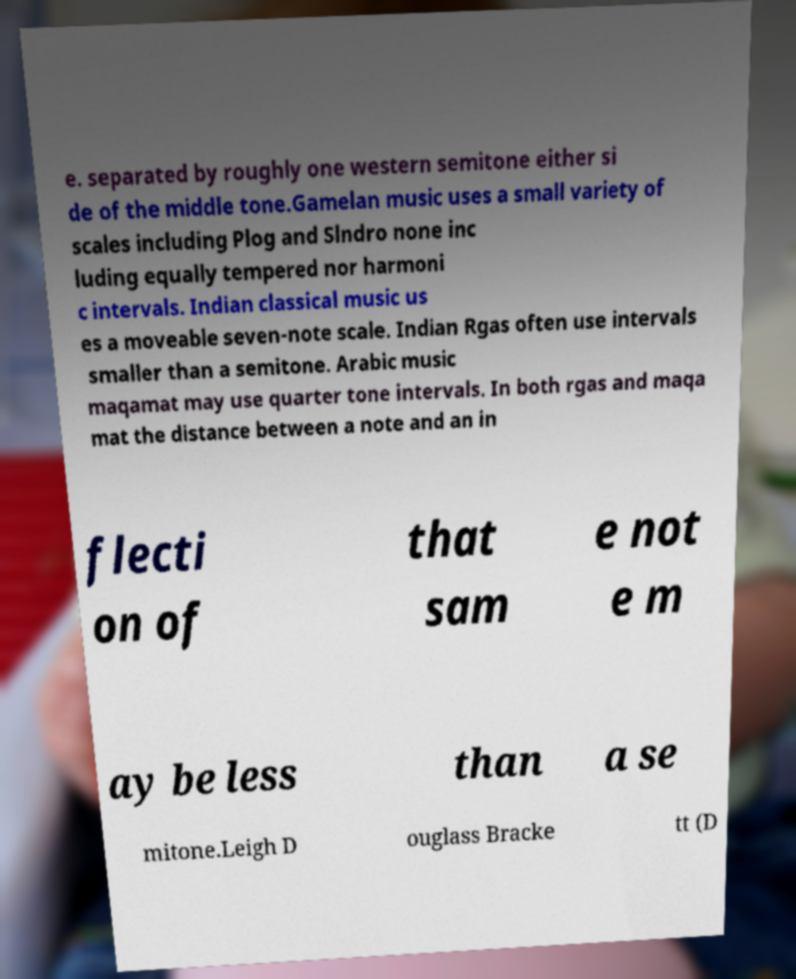There's text embedded in this image that I need extracted. Can you transcribe it verbatim? e. separated by roughly one western semitone either si de of the middle tone.Gamelan music uses a small variety of scales including Plog and Slndro none inc luding equally tempered nor harmoni c intervals. Indian classical music us es a moveable seven-note scale. Indian Rgas often use intervals smaller than a semitone. Arabic music maqamat may use quarter tone intervals. In both rgas and maqa mat the distance between a note and an in flecti on of that sam e not e m ay be less than a se mitone.Leigh D ouglass Bracke tt (D 